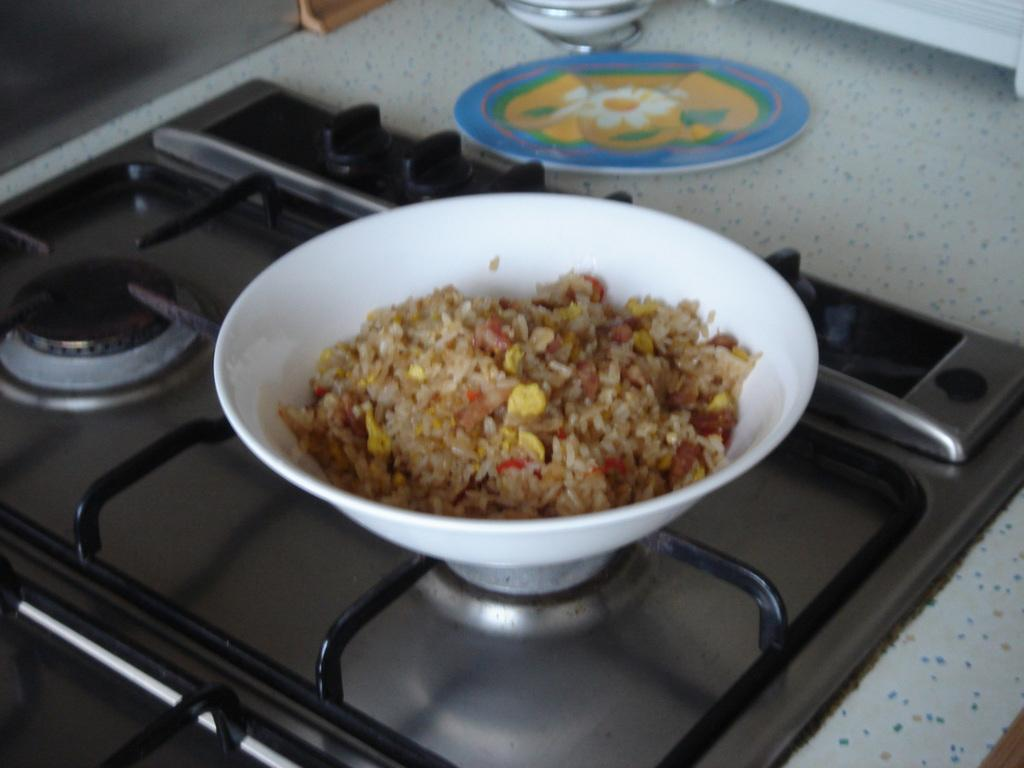What is in the bowl that is visible in the image? There is food in a bowl in the image. Where is the bowl located in the image? The bowl is placed on a stove in the image. What other item can be seen beside the bowl? There is a plate beside the bowl in the image. What word is written on the plate in the image? There is no word written on the plate in the image. Is there any eggnog visible in the image? There is no eggnog present in the image. 